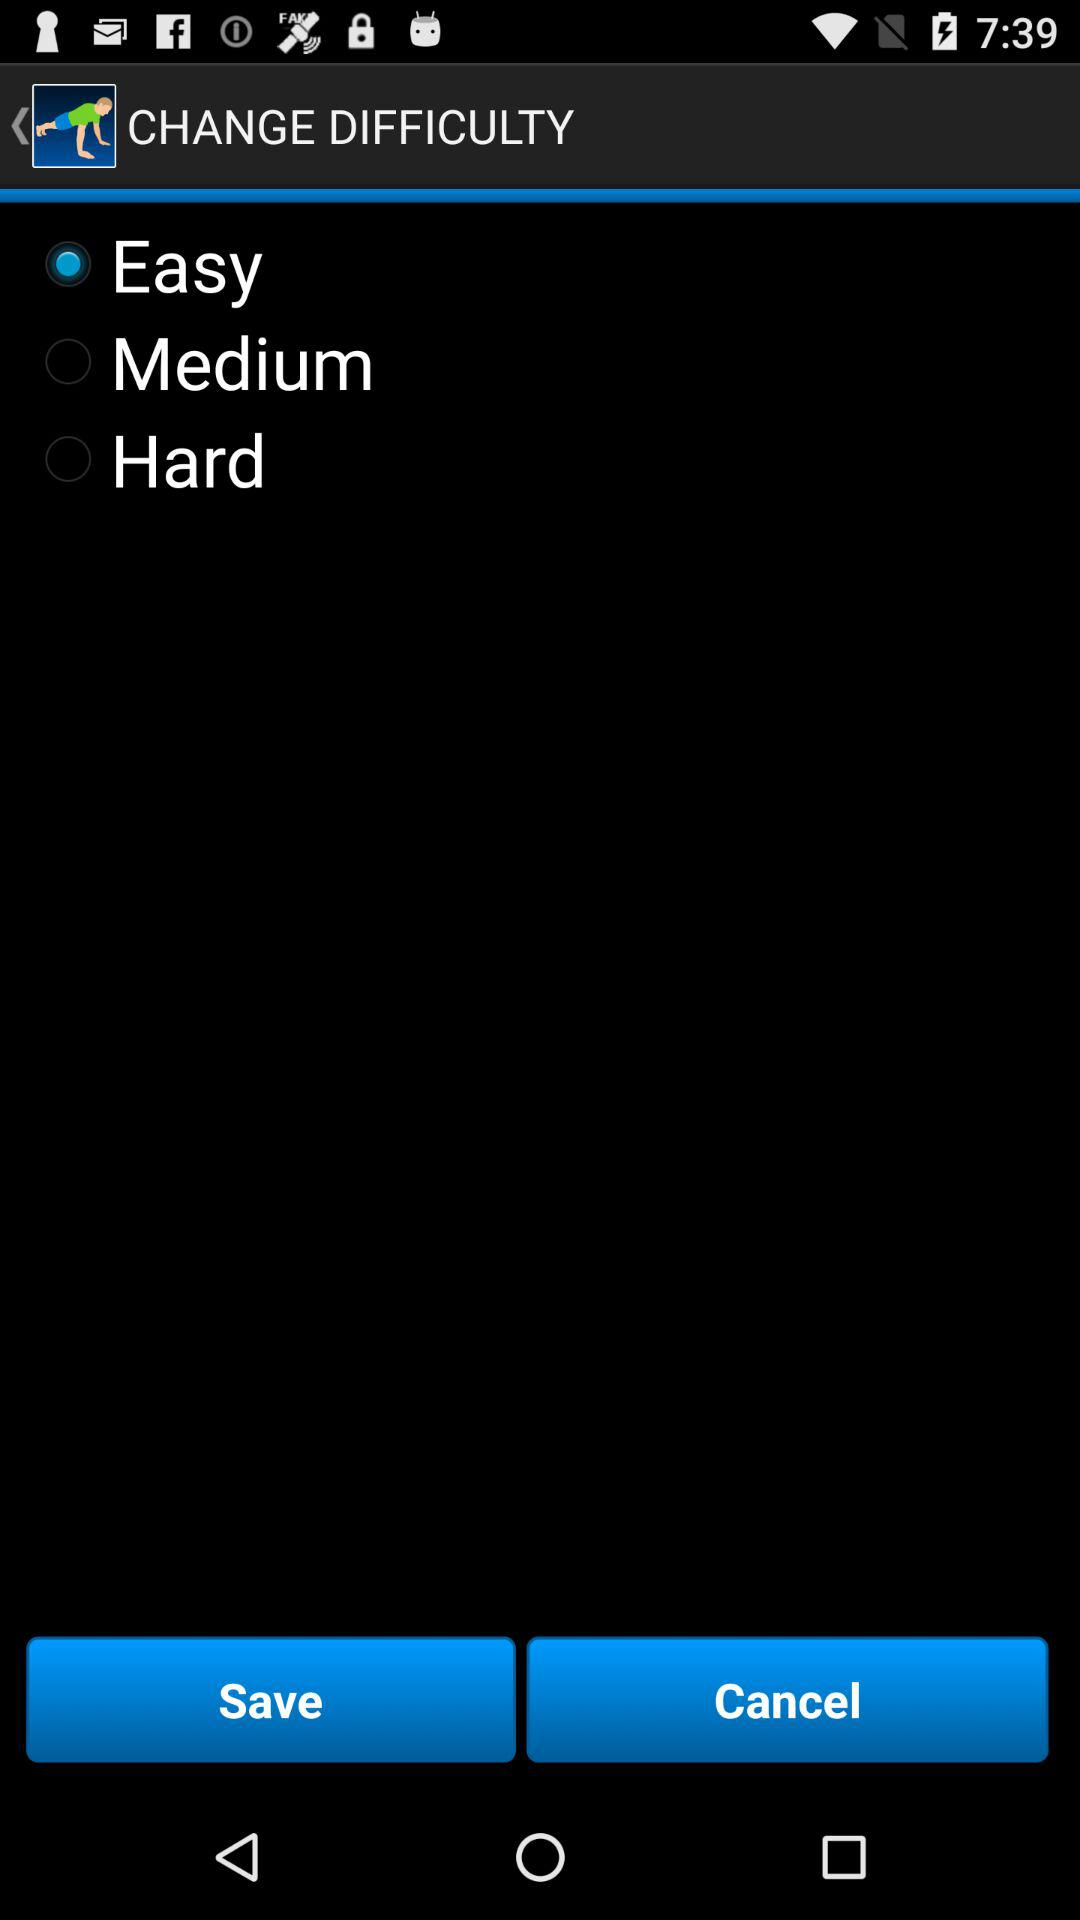Which option is selected? The selected option is "Easy". 